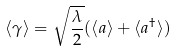Convert formula to latex. <formula><loc_0><loc_0><loc_500><loc_500>\langle \gamma \rangle = \sqrt { \frac { \lambda } { 2 } } ( \langle a \rangle + \langle a ^ { \dagger } \rangle )</formula> 